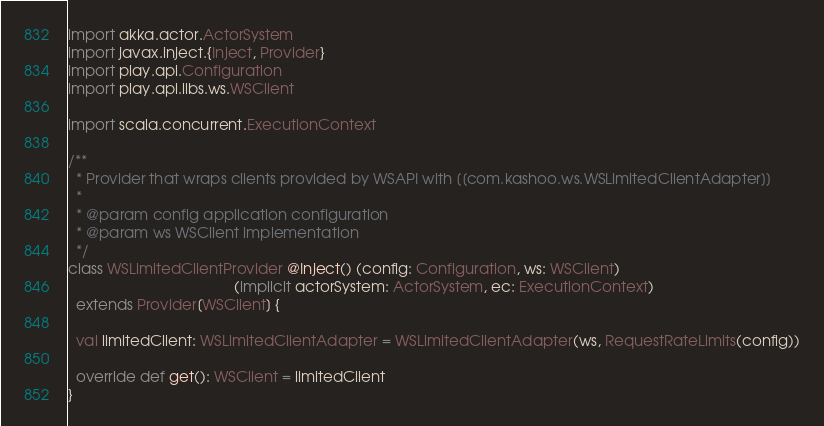<code> <loc_0><loc_0><loc_500><loc_500><_Scala_>import akka.actor.ActorSystem
import javax.inject.{Inject, Provider}
import play.api.Configuration
import play.api.libs.ws.WSClient

import scala.concurrent.ExecutionContext

/**
  * Provider that wraps clients provided by WSAPI with [[com.kashoo.ws.WSLimitedClientAdapter]]
  *
  * @param config application configuration
  * @param ws WSClient implementation
  */
class WSLimitedClientProvider @Inject() (config: Configuration, ws: WSClient)
                                        (implicit actorSystem: ActorSystem, ec: ExecutionContext)
  extends Provider[WSClient] {

  val limitedClient: WSLimitedClientAdapter = WSLimitedClientAdapter(ws, RequestRateLimits(config))

  override def get(): WSClient = limitedClient
}
</code> 